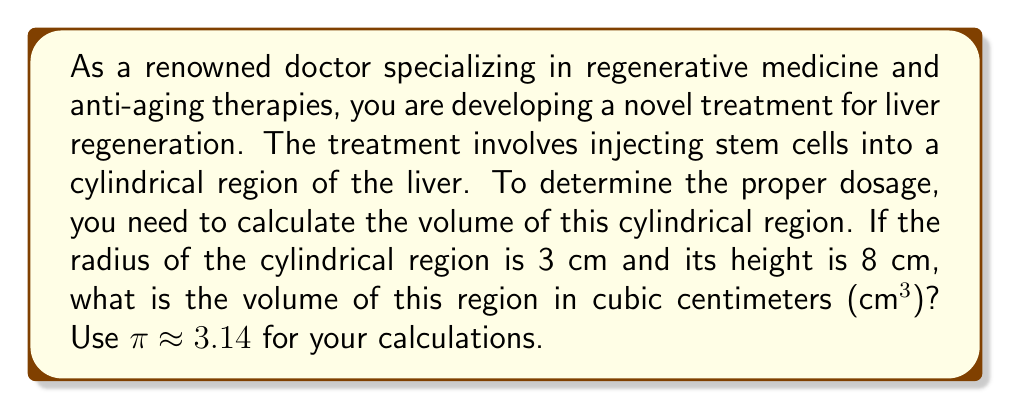Can you solve this math problem? To solve this problem, we need to use the formula for the volume of a cylinder:

$$V = \pi r^2 h$$

Where:
$V$ = volume of the cylinder
$\pi$ = pi (approximately 3.14)
$r$ = radius of the base of the cylinder
$h$ = height of the cylinder

Given:
$r = 3$ cm
$h = 8$ cm
$\pi \approx 3.14$

Let's substitute these values into the formula:

$$\begin{align*}
V &= \pi r^2 h \\
&= 3.14 \times (3\text{ cm})^2 \times 8\text{ cm} \\
&= 3.14 \times 9\text{ cm}^2 \times 8\text{ cm} \\
&= 226.08\text{ cm}^3
\end{align*}$$

Therefore, the volume of the cylindrical region in the liver is approximately 226.08 cm³.
Answer: 226.08 cm³ 